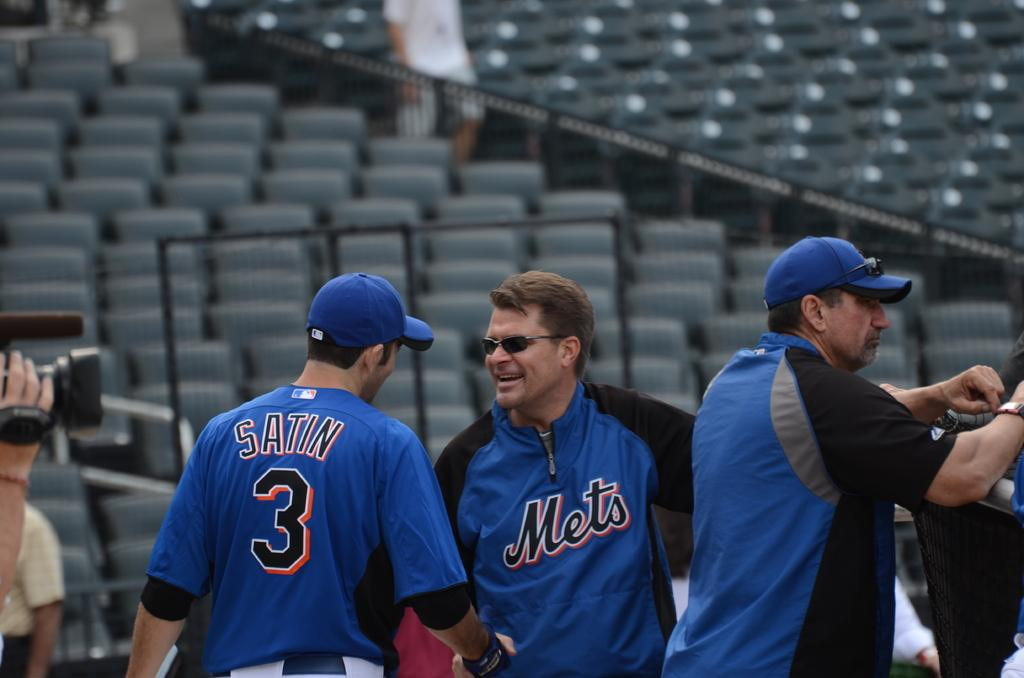<image>
Give a short and clear explanation of the subsequent image. Three men wearing blue mets shirts are speaking with one of them having the number 3 on his back. 